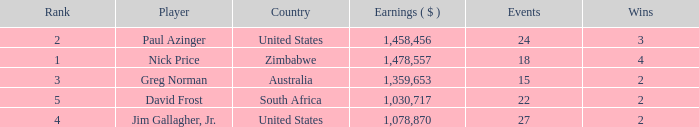How many events are in South Africa? 22.0. Parse the table in full. {'header': ['Rank', 'Player', 'Country', 'Earnings ( $ )', 'Events', 'Wins'], 'rows': [['2', 'Paul Azinger', 'United States', '1,458,456', '24', '3'], ['1', 'Nick Price', 'Zimbabwe', '1,478,557', '18', '4'], ['3', 'Greg Norman', 'Australia', '1,359,653', '15', '2'], ['5', 'David Frost', 'South Africa', '1,030,717', '22', '2'], ['4', 'Jim Gallagher, Jr.', 'United States', '1,078,870', '27', '2']]} 